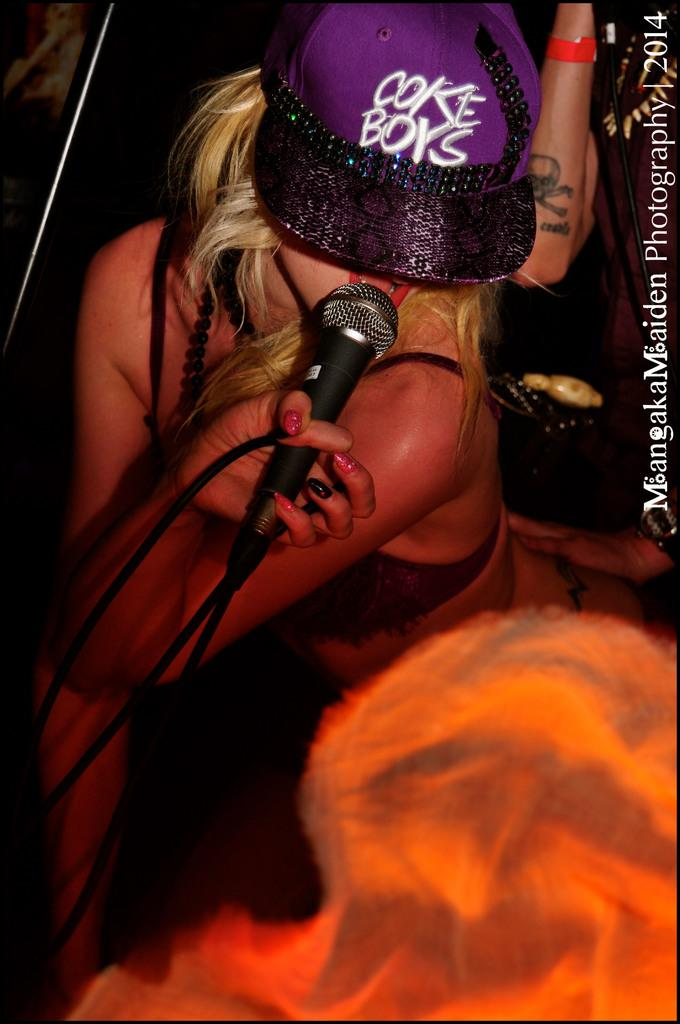Who is the main subject in the image? There is a woman in the image. What is the woman doing in the image? The woman is sitting and singing. What object is the woman holding in her hand? The woman is holding a mic in her hand. Can you describe the background of the image? There is a person and a bag in the background of the image. How does the woman's singing affect the pollution levels in the image? The image does not show any pollution, and therefore it cannot be determined how the woman's singing affects it. 